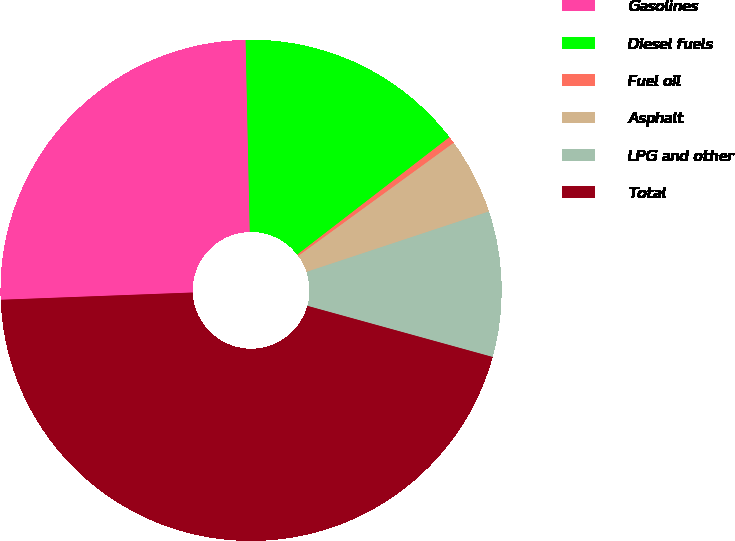Convert chart to OTSL. <chart><loc_0><loc_0><loc_500><loc_500><pie_chart><fcel>Gasolines<fcel>Diesel fuels<fcel>Fuel oil<fcel>Asphalt<fcel>LPG and other<fcel>Total<nl><fcel>25.26%<fcel>14.88%<fcel>0.45%<fcel>4.92%<fcel>9.38%<fcel>45.11%<nl></chart> 